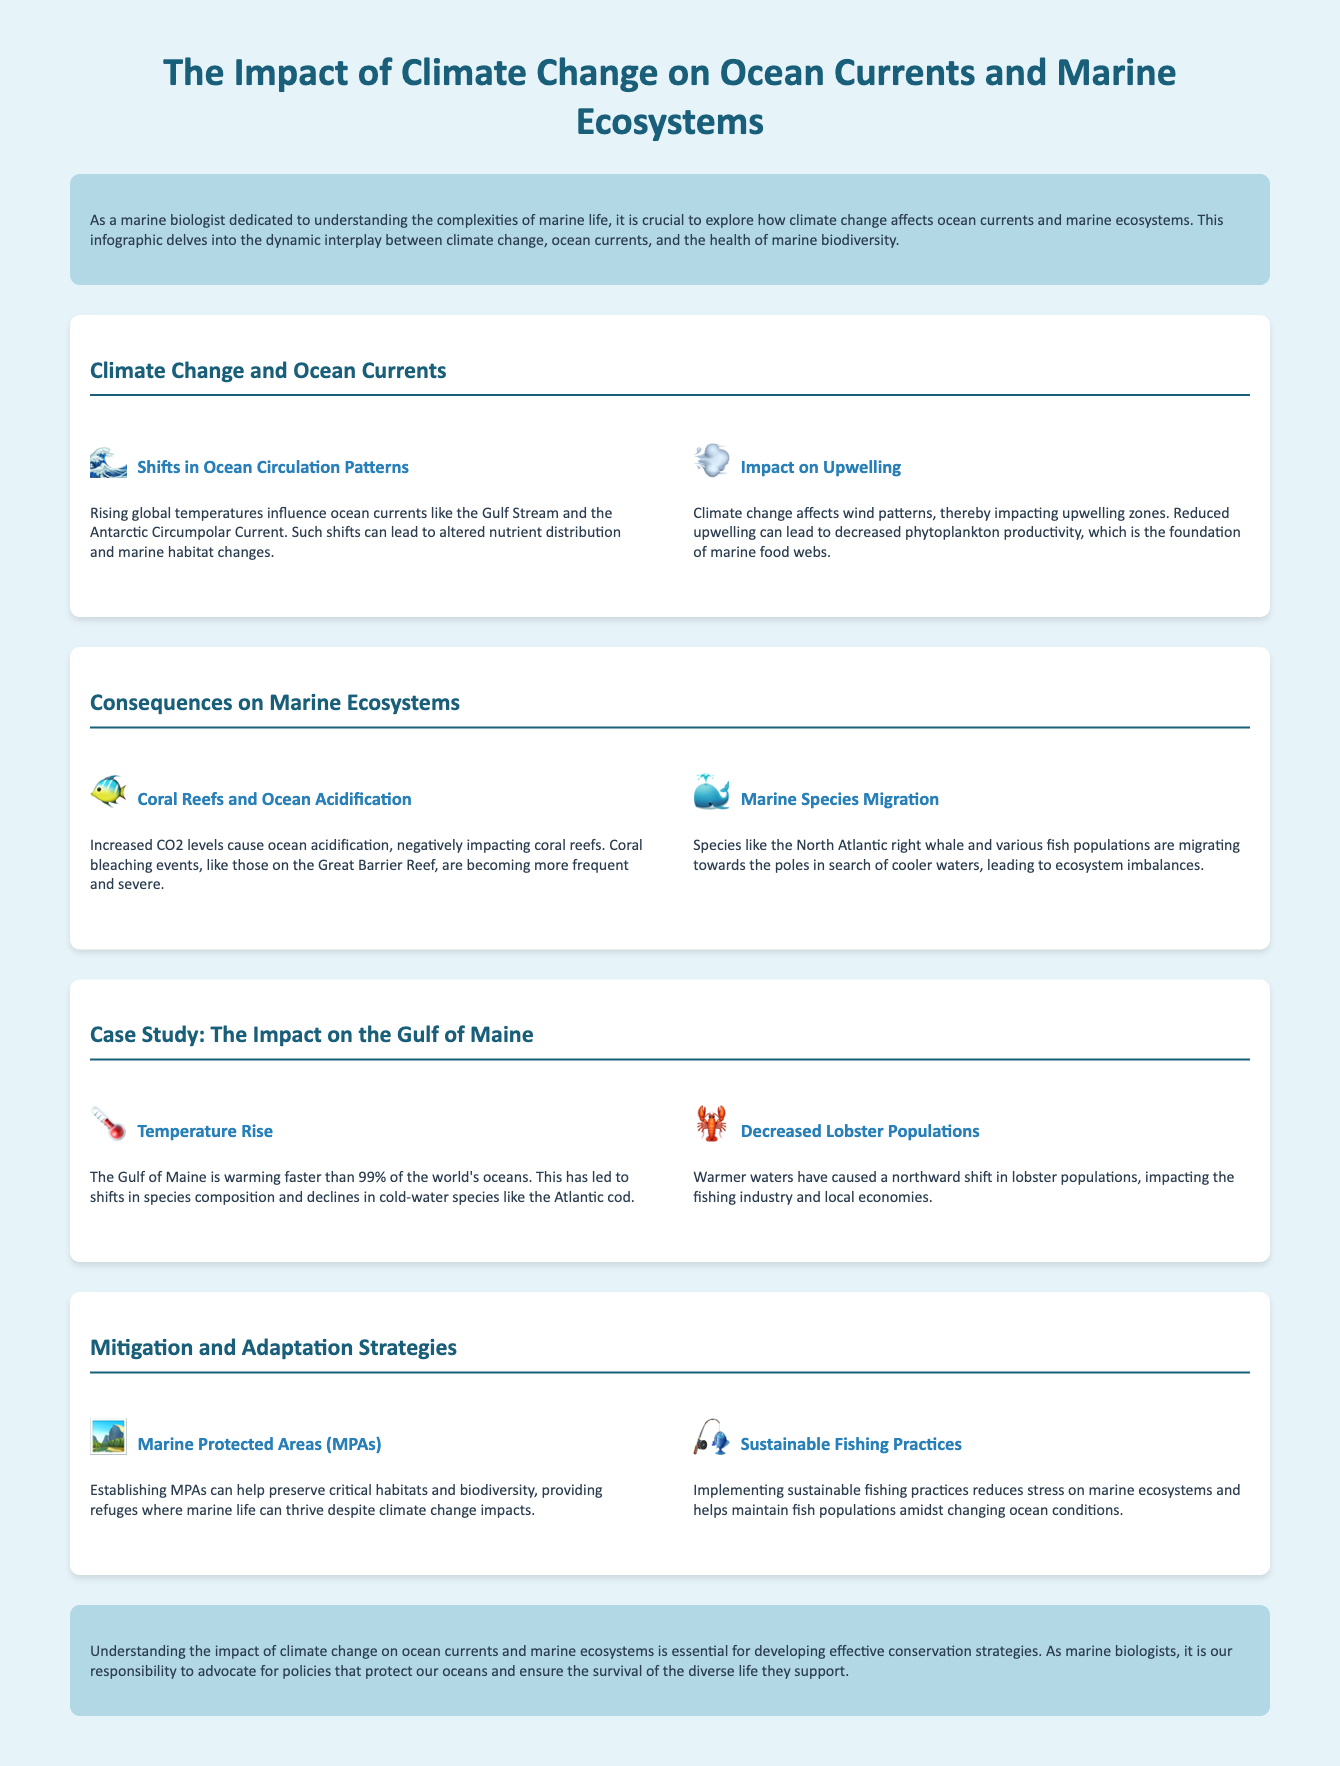what is the title of the infographic? The title of the infographic is mentioned at the top of the document.
Answer: The Impact of Climate Change on Ocean Currents and Marine Ecosystems what is the impact of climate change on upwelling? The effect of climate change on upwelling is discussed in the section that talks about wind patterns.
Answer: Reduced upwelling which marine species is specifically mentioned as migrating due to climate change? The document provides an example of a species that is migrating in search of cooler waters.
Answer: North Atlantic right whale what is occurring more frequently and severely according to the document? The infographic discusses a specific phenomenon affecting coral reefs, linking it to climate change.
Answer: Coral bleaching events how much faster is the Gulf of Maine warming compared to the rest of the world's oceans? The document provides a comparison of the Gulf of Maine's warming rate to the world's oceans.
Answer: Faster than 99% what are Marine Protected Areas designed to preserve? This question refers to a strategy aimed at helping marine life in the context of climate change.
Answer: Critical habitats and biodiversity what example of a marine species has shown a population decrease? The infographic mentions a specific species that is declining due to warmer waters.
Answer: Atlantic cod what strategy can help maintain fish populations? The document suggests specific practices to support marine ecosystems amidst changing conditions.
Answer: Sustainable fishing practices 